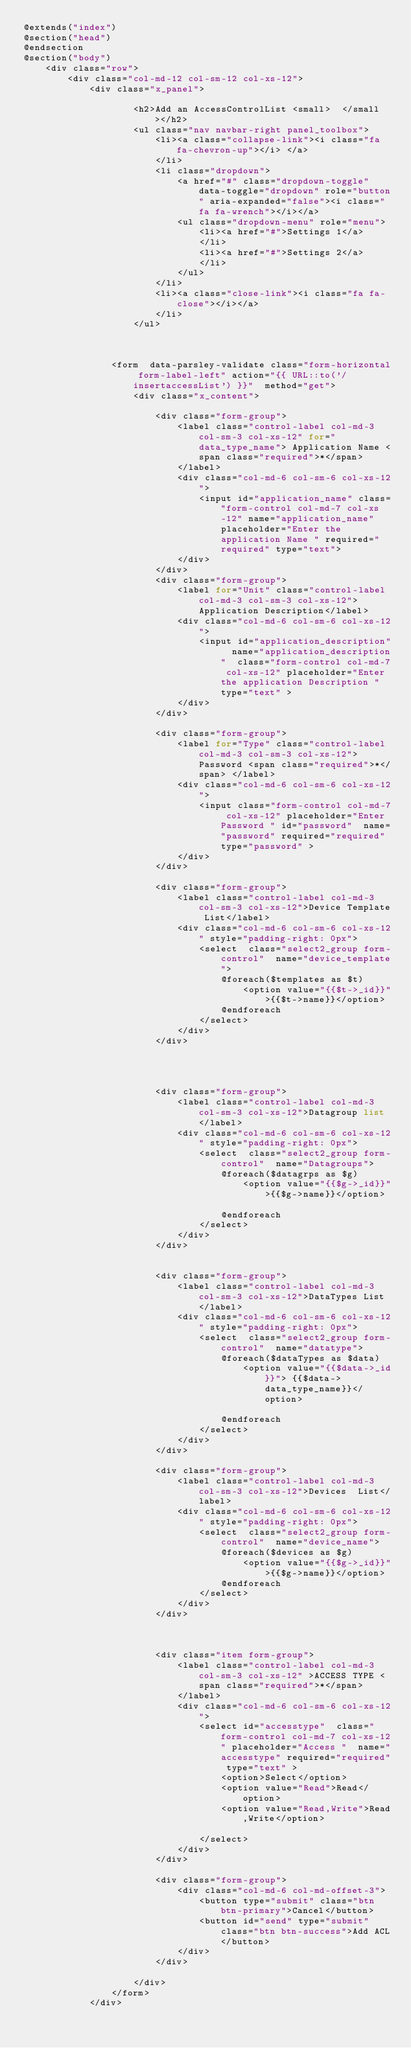<code> <loc_0><loc_0><loc_500><loc_500><_PHP_>@extends("index")
@section("head")
@endsection
@section("body")
    <div class="row">
        <div class="col-md-12 col-sm-12 col-xs-12">
            <div class="x_panel">

                    <h2>Add an AccessControlList <small>  </small></h2>
                    <ul class="nav navbar-right panel_toolbox">
                        <li><a class="collapse-link"><i class="fa fa-chevron-up"></i> </a>
                        </li>
                        <li class="dropdown">
                            <a href="#" class="dropdown-toggle" data-toggle="dropdown" role="button" aria-expanded="false"><i class="fa fa-wrench"></i></a>
                            <ul class="dropdown-menu" role="menu">
                                <li><a href="#">Settings 1</a>
                                </li>
                                <li><a href="#">Settings 2</a>
                                </li>
                            </ul>
                        </li>
                        <li><a class="close-link"><i class="fa fa-close"></i></a>
                        </li>
                    </ul>



                <form  data-parsley-validate class="form-horizontal form-label-left" action="{{ URL::to('/insertaccessList') }}"  method="get">
                    <div class="x_content">

                        <div class="form-group">
                            <label class="control-label col-md-3 col-sm-3 col-xs-12" for="data_type_name"> Application Name <span class="required">*</span>
                            </label>
                            <div class="col-md-6 col-sm-6 col-xs-12">
                                <input id="application_name" class="form-control col-md-7 col-xs-12" name="application_name" placeholder="Enter the application Name " required="required" type="text">
                            </div>
                        </div>
                        <div class="form-group">
                            <label for="Unit" class="control-label col-md-3 col-sm-3 col-xs-12">  Application Description</label>
                            <div class="col-md-6 col-sm-6 col-xs-12">
                                <input id="application_description"  name="application_description"  class="form-control col-md-7 col-xs-12" placeholder="Enter the application Description "  type="text" >
                            </div>
                        </div>

                        <div class="form-group">
                            <label for="Type" class="control-label col-md-3 col-sm-3 col-xs-12">  Password <span class="required">*</span> </label>
                            <div class="col-md-6 col-sm-6 col-xs-12">
                                <input class="form-control col-md-7 col-xs-12" placeholder="Enter Password " id="password"  name="password" required="required" type="password" >
                            </div>
                        </div>

                        <div class="form-group">
                            <label class="control-label col-md-3 col-sm-3 col-xs-12">Device Template List</label>
                            <div class="col-md-6 col-sm-6 col-xs-12" style="padding-right: 0px">
                                <select  class="select2_group form-control"  name="device_template">
                                    @foreach($templates as $t)
                                        <option value="{{$t->_id}}">{{$t->name}}</option>
                                    @endforeach
                                </select>
                            </div>
                        </div>




                        <div class="form-group">
                            <label class="control-label col-md-3 col-sm-3 col-xs-12">Datagroup list</label>
                            <div class="col-md-6 col-sm-6 col-xs-12" style="padding-right: 0px">
                                <select  class="select2_group form-control"  name="Datagroups">
                                    @foreach($datagrps as $g)
                                        <option value="{{$g->_id}}">{{$g->name}}</option>

                                    @endforeach
                                </select>
                            </div>
                        </div>


                        <div class="form-group">
                            <label class="control-label col-md-3 col-sm-3 col-xs-12">DataTypes List</label>
                            <div class="col-md-6 col-sm-6 col-xs-12" style="padding-right: 0px">
                                <select  class="select2_group form-control"  name="datatype">
                                    @foreach($dataTypes as $data)
                                        <option value="{{$data->_id}}"> {{$data->data_type_name}}</option>

                                    @endforeach
                                </select>
                            </div>
                        </div>

                        <div class="form-group">
                            <label class="control-label col-md-3 col-sm-3 col-xs-12">Devices  List</label>
                            <div class="col-md-6 col-sm-6 col-xs-12" style="padding-right: 0px">
                                <select  class="select2_group form-control"  name="device_name">
                                    @foreach($devices as $g)
                                        <option value="{{$g->_id}}">{{$g->name}}</option>
                                    @endforeach
                                </select>
                            </div>
                        </div>



                        <div class="item form-group">
                            <label class="control-label col-md-3 col-sm-3 col-xs-12" >ACCESS TYPE <span class="required">*</span>
                            </label>
                            <div class="col-md-6 col-sm-6 col-xs-12">
                                <select id="accesstype"  class="form-control col-md-7 col-xs-12" placeholder="Access "  name="accesstype" required="required" type="text" >
                                    <option>Select</option>
                                    <option value="Read">Read</option>
                                    <option value="Read,Write">Read,Write</option>

                                </select>
                            </div>
                        </div>

                        <div class="form-group">
                            <div class="col-md-6 col-md-offset-3">
                                <button type="submit" class="btn btn-primary">Cancel</button>
                                <button id="send" type="submit" class="btn btn-success">Add ACL</button>
                            </div>
                        </div>

                    </div>
                </form>
            </div></code> 